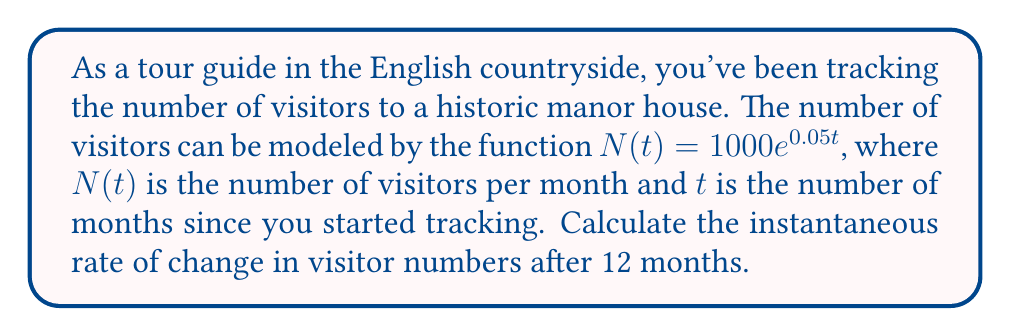What is the answer to this math problem? To find the instantaneous rate of change, we need to calculate the derivative of the function $N(t)$ and evaluate it at $t = 12$.

Step 1: Find the derivative of $N(t)$
$$\frac{d}{dt}N(t) = \frac{d}{dt}(1000e^{0.05t})$$
Using the chain rule:
$$N'(t) = 1000 \cdot 0.05e^{0.05t} = 50e^{0.05t}$$

Step 2: Evaluate $N'(t)$ at $t = 12$
$$N'(12) = 50e^{0.05(12)} = 50e^{0.6}$$

Step 3: Calculate the final value
$$N'(12) = 50 \cdot 1.8221 \approx 91.105$$

This means that after 12 months, the number of visitors is increasing at a rate of approximately 91.105 visitors per month.
Answer: 91.105 visitors/month 